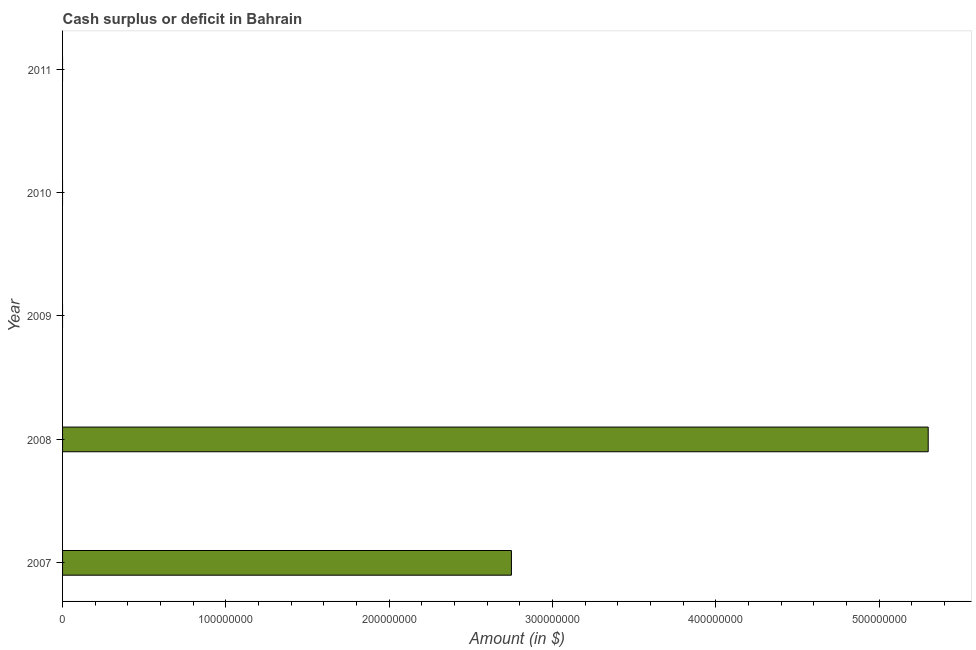What is the title of the graph?
Offer a very short reply. Cash surplus or deficit in Bahrain. What is the label or title of the X-axis?
Offer a terse response. Amount (in $). Across all years, what is the maximum cash surplus or deficit?
Provide a short and direct response. 5.30e+08. Across all years, what is the minimum cash surplus or deficit?
Give a very brief answer. 0. In which year was the cash surplus or deficit maximum?
Offer a terse response. 2008. What is the sum of the cash surplus or deficit?
Offer a terse response. 8.05e+08. What is the average cash surplus or deficit per year?
Offer a very short reply. 1.61e+08. What is the median cash surplus or deficit?
Your answer should be very brief. 0. What is the ratio of the cash surplus or deficit in 2007 to that in 2008?
Your answer should be compact. 0.52. Is the difference between the cash surplus or deficit in 2007 and 2008 greater than the difference between any two years?
Keep it short and to the point. No. What is the difference between the highest and the lowest cash surplus or deficit?
Offer a very short reply. 5.30e+08. In how many years, is the cash surplus or deficit greater than the average cash surplus or deficit taken over all years?
Your response must be concise. 2. How many years are there in the graph?
Ensure brevity in your answer.  5. What is the difference between two consecutive major ticks on the X-axis?
Offer a very short reply. 1.00e+08. What is the Amount (in $) of 2007?
Your response must be concise. 2.75e+08. What is the Amount (in $) of 2008?
Keep it short and to the point. 5.30e+08. What is the Amount (in $) in 2009?
Make the answer very short. 0. What is the Amount (in $) in 2010?
Ensure brevity in your answer.  0. What is the Amount (in $) in 2011?
Your response must be concise. 0. What is the difference between the Amount (in $) in 2007 and 2008?
Your answer should be compact. -2.55e+08. What is the ratio of the Amount (in $) in 2007 to that in 2008?
Provide a succinct answer. 0.52. 